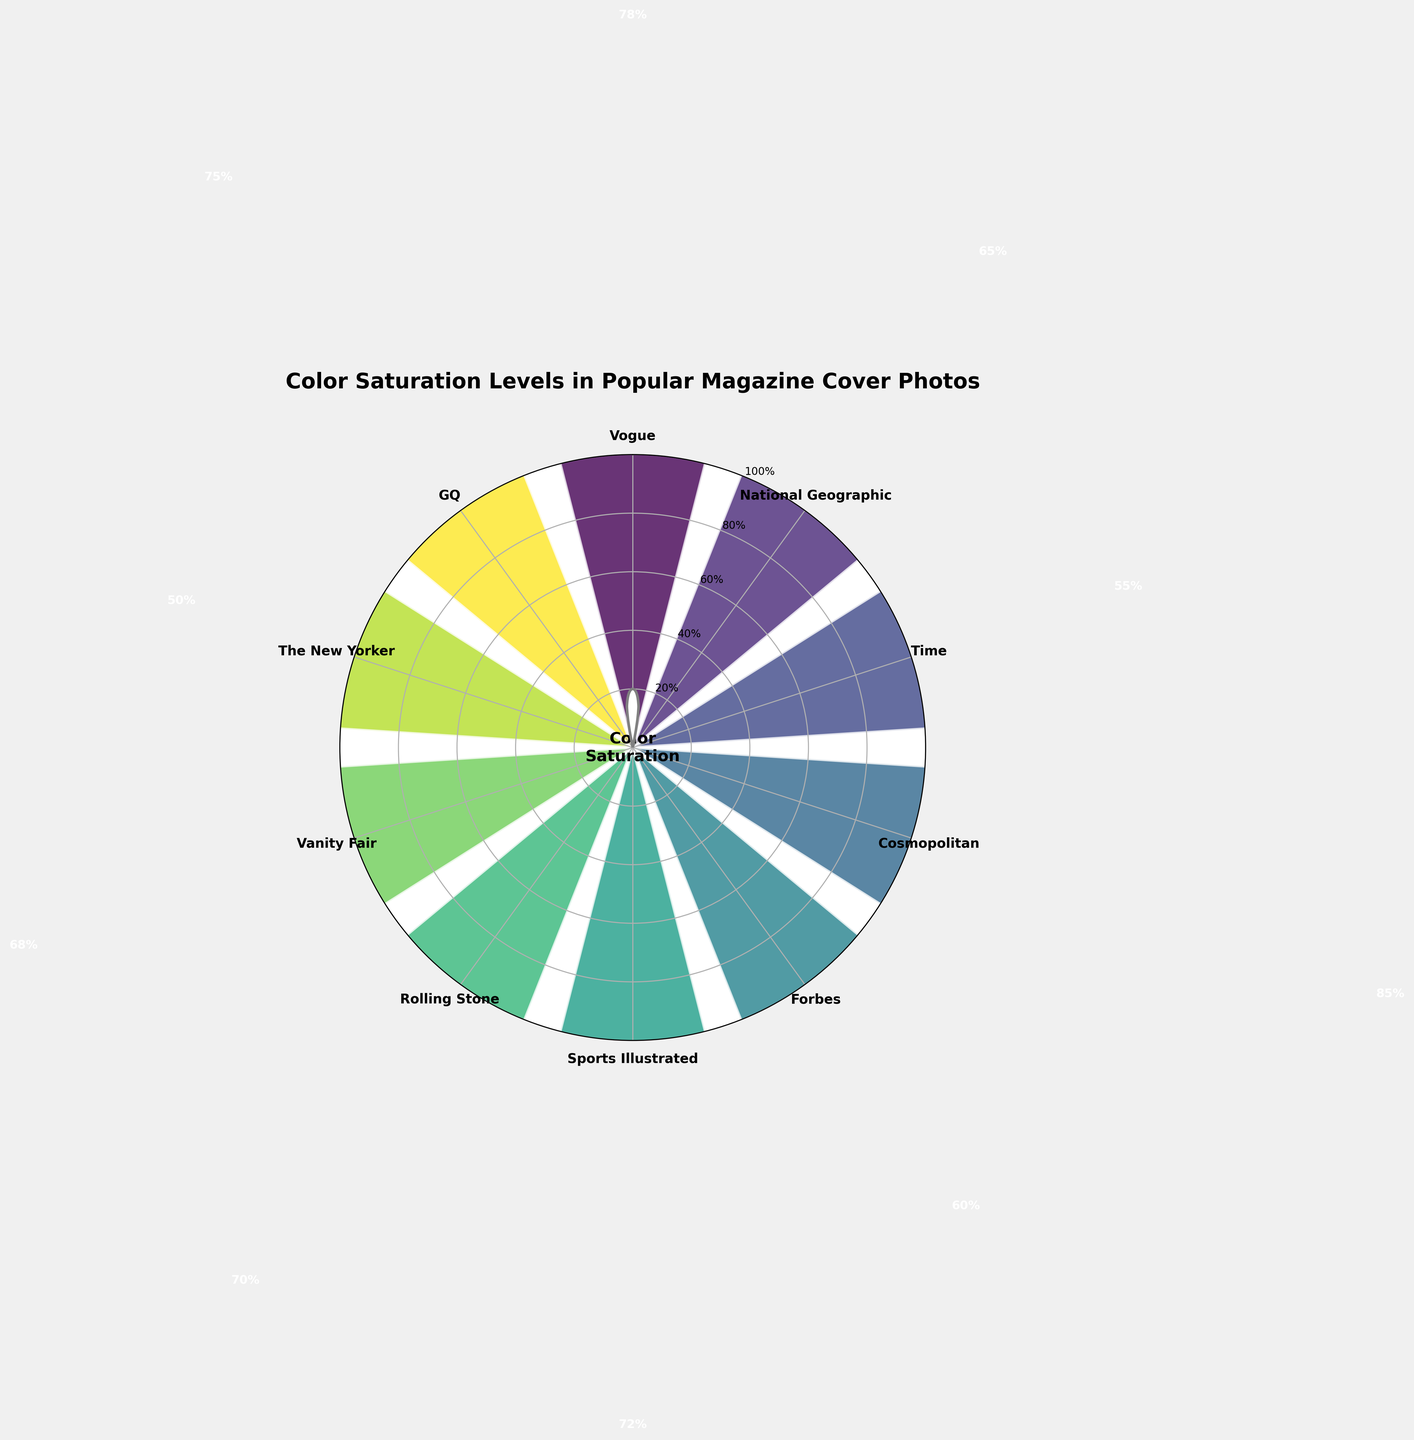How many magazines are analyzed in the figure? Count the number of magazines listed on the outer circle of the gauge chart.
Answer: 10 Which magazine has the highest color saturation level? Identify the bar that extends the furthest towards the outer edge of the chart.
Answer: Cosmopolitan What is the color saturation level of Time magazine? Locate the label for Time magazine and note the percentage associated with its bar.
Answer: 55% Which magazine has a color saturation level closest to 70%? Compare the bars close to the 70% mark and identify the corresponding magazine.
Answer: Rolling Stone How does the color saturation level of Vogue compare to that of GQ? Find Vogue and GQ on the chart, and compare the heights of their respective bars.
Answer: Vogue is higher than GQ What is the difference in color saturation level between Vanity Fair and National Geographic? Subtract the color saturation level of National Geographic from that of Vanity Fair (68 - 65).
Answer: 3% Which magazines have color saturation levels greater than 70%? Identify bars that extend beyond the 70% mark and list their corresponding magazines.
Answer: Vogue, Cosmopolitan, GQ What is the average color saturation level of all the magazines? Add up all the color saturation levels and divide by the number of magazines (78 + 65 + 55 + 85 + 60 + 72 + 70 + 68 + 50 + 75) / 10.
Answer: 67.8% What is the median color saturation level of the magazines? List all the saturation levels in ascending order and find the middle value (or the average of the two middle values).
Answer: 68% Which magazine has the lowest color saturation level, and what is it? Identify the bar closest to the center of the chart and note the corresponding magazine and percentage.
Answer: The New Yorker, 50% 